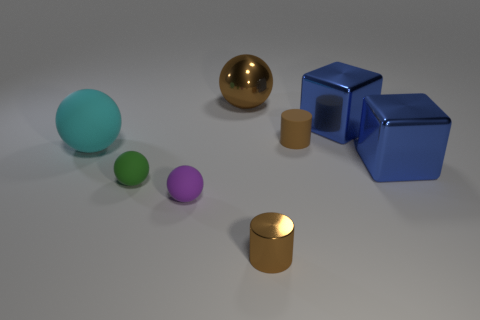Based on this image, what can we infer about the purpose of these objects? The objects in the image do not appear to have a practical use as they are simplistic geometric shapes. Their purpose seems to be more artistic or educational, perhaps used for a display, as part of a rendering test for 3D modeling software, or for teaching geometry and spatial relations. 